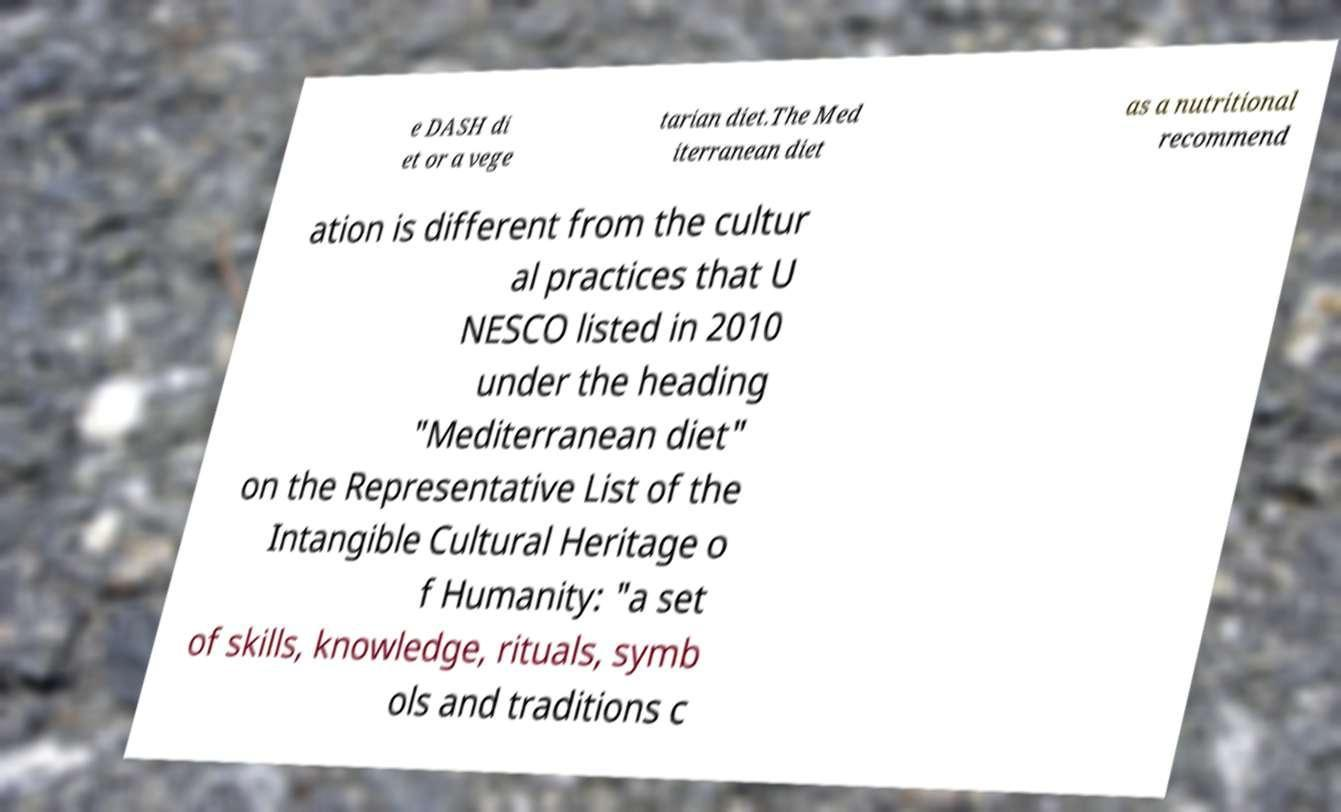I need the written content from this picture converted into text. Can you do that? e DASH di et or a vege tarian diet.The Med iterranean diet as a nutritional recommend ation is different from the cultur al practices that U NESCO listed in 2010 under the heading "Mediterranean diet" on the Representative List of the Intangible Cultural Heritage o f Humanity: "a set of skills, knowledge, rituals, symb ols and traditions c 